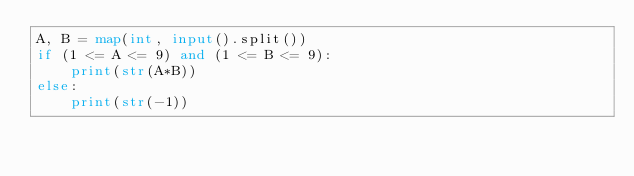<code> <loc_0><loc_0><loc_500><loc_500><_Python_>A, B = map(int, input().split())
if (1 <= A <= 9) and (1 <= B <= 9):
    print(str(A*B))
else:
    print(str(-1))
</code> 